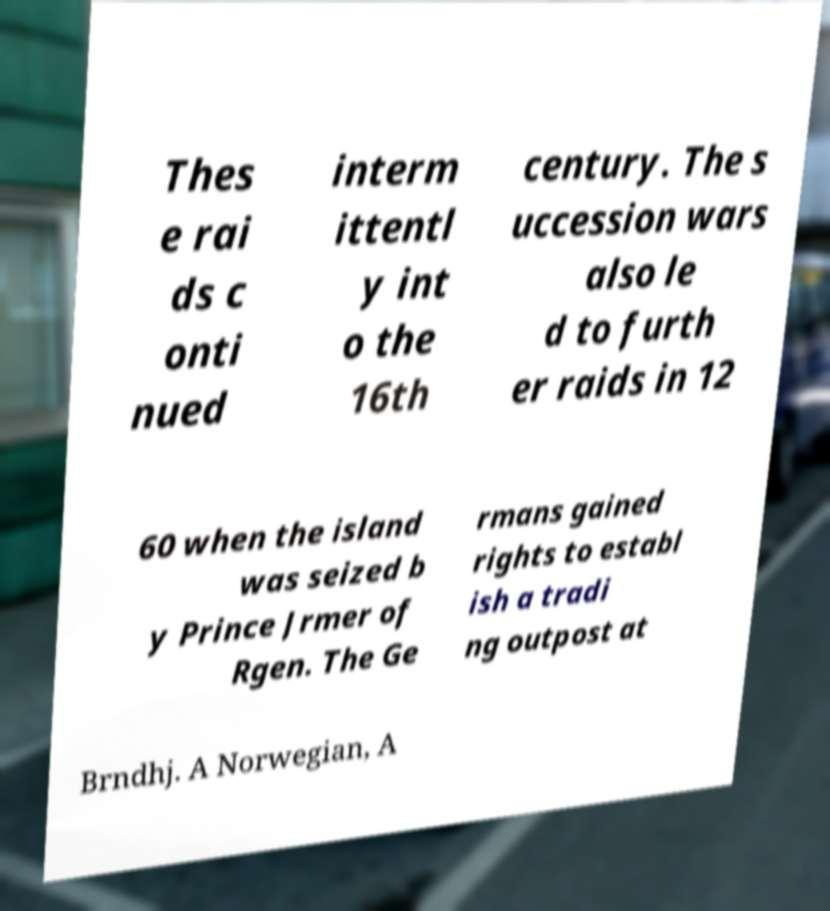Can you accurately transcribe the text from the provided image for me? Thes e rai ds c onti nued interm ittentl y int o the 16th century. The s uccession wars also le d to furth er raids in 12 60 when the island was seized b y Prince Jrmer of Rgen. The Ge rmans gained rights to establ ish a tradi ng outpost at Brndhj. A Norwegian, A 